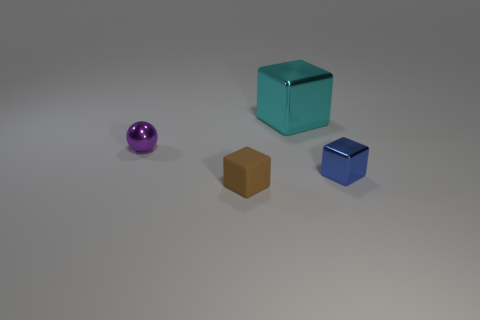How many other objects are the same color as the metallic sphere?
Provide a short and direct response. 0. Are there fewer big metallic objects that are in front of the tiny matte thing than brown matte blocks?
Provide a succinct answer. Yes. How many green rubber spheres are there?
Provide a short and direct response. 0. How many cyan cubes are the same material as the tiny purple thing?
Make the answer very short. 1. What number of objects are either metal things that are right of the purple metallic thing or small blue blocks?
Your answer should be very brief. 2. Is the number of balls that are behind the purple shiny object less than the number of cyan objects left of the cyan metallic block?
Make the answer very short. No. There is a blue cube; are there any rubber blocks on the right side of it?
Provide a succinct answer. No. What number of things are blocks left of the blue object or small objects behind the blue object?
Offer a very short reply. 3. What number of small matte blocks are the same color as the sphere?
Provide a succinct answer. 0. The big metallic object that is the same shape as the small brown object is what color?
Keep it short and to the point. Cyan. 